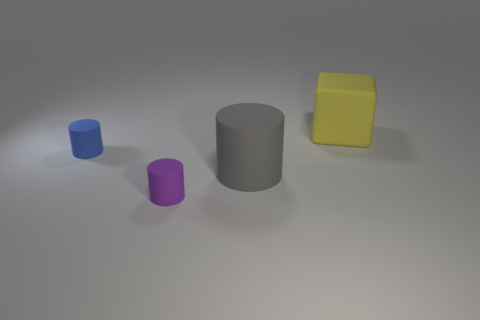Considering their colors, how do these objects make you feel? The combination of colors—calming blue, vibrant purple, neutral gray, and bright yellow—creates a balanced and harmonious feeling, evoking a sense of simplicity and order. 